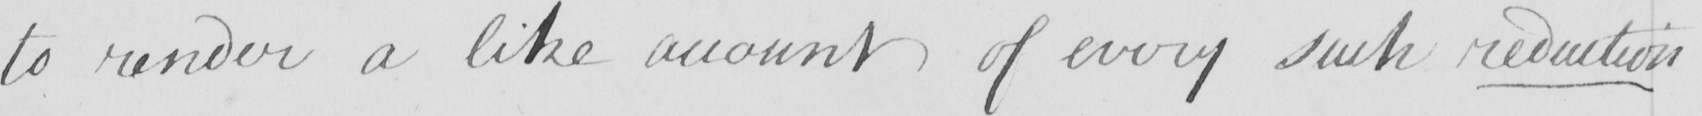Can you tell me what this handwritten text says? to render a like account of every such reduction 